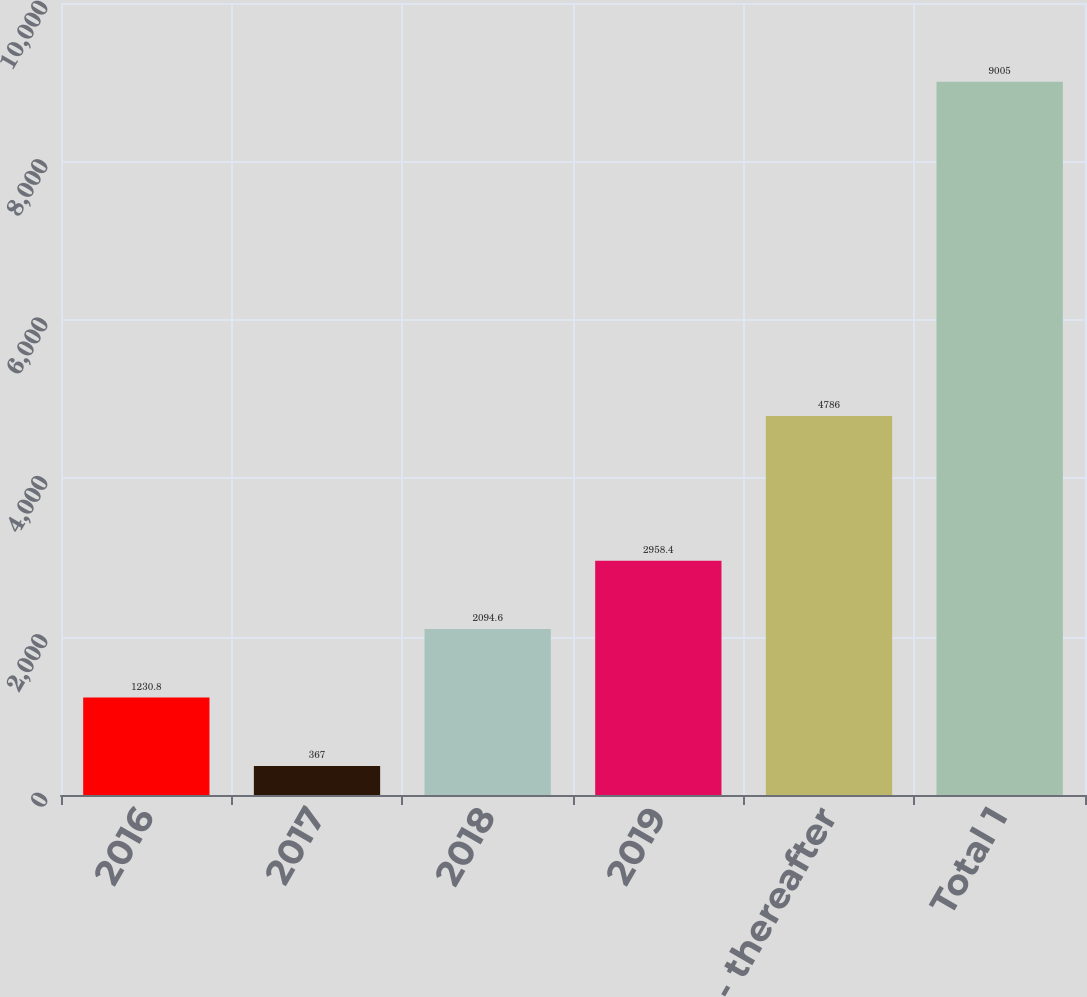Convert chart to OTSL. <chart><loc_0><loc_0><loc_500><loc_500><bar_chart><fcel>2016<fcel>2017<fcel>2018<fcel>2019<fcel>2020 - thereafter<fcel>Total 1<nl><fcel>1230.8<fcel>367<fcel>2094.6<fcel>2958.4<fcel>4786<fcel>9005<nl></chart> 